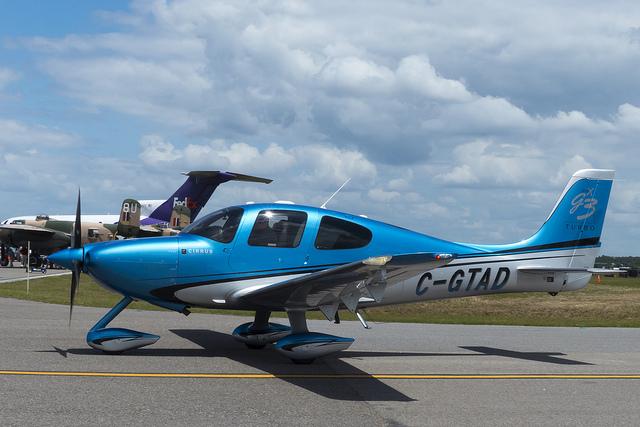What large letters are on the plane?
Short answer required. C-gtad. What main color is the plane?
Short answer required. Blue. What else is visible?
Quick response, please. Plane. 